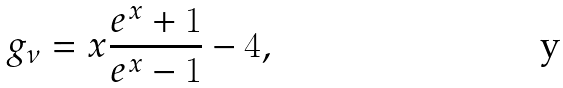<formula> <loc_0><loc_0><loc_500><loc_500>g _ { \nu } = x \frac { e ^ { x } + 1 } { e ^ { x } - 1 } - 4 ,</formula> 